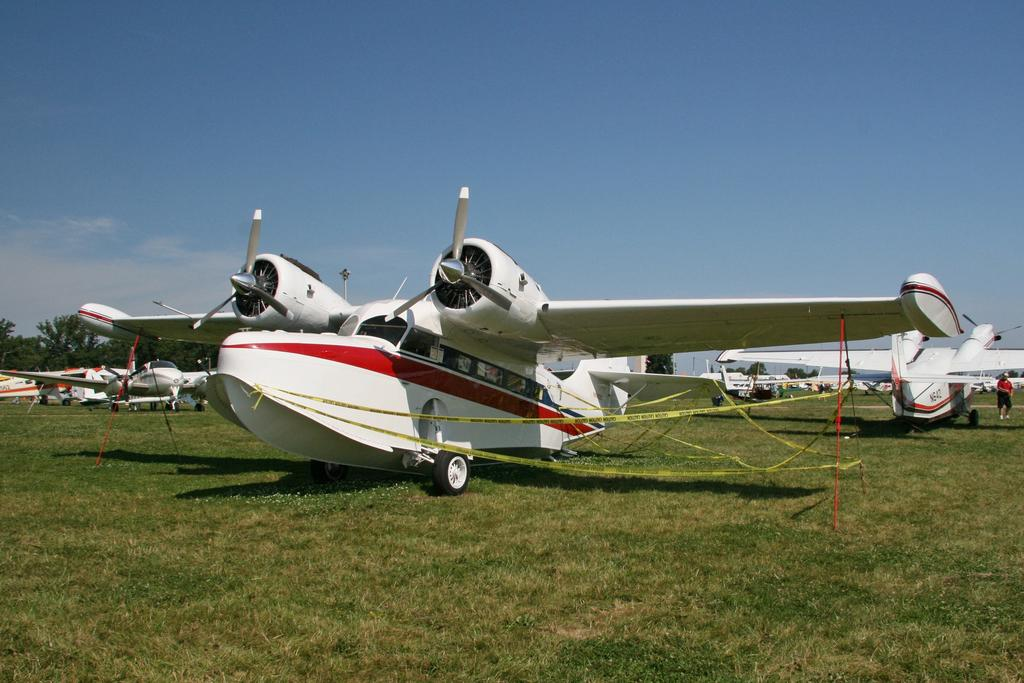What color is the aircraft on the ground in the image? The aircraft on the ground is white. Can you describe the other aircrafts in the image? There are more aircrafts visible in the background. What can be seen in the background besides the aircrafts? There are trees in the background. How would you describe the sky in the image? The sky is blue with clouds. What type of poison is being used to attempt to believe in the image? There is no mention of poison, belief, or an attempt in the image. The image features an aircraft on the ground and other aircrafts in the background, along with trees and a blue sky with clouds. 